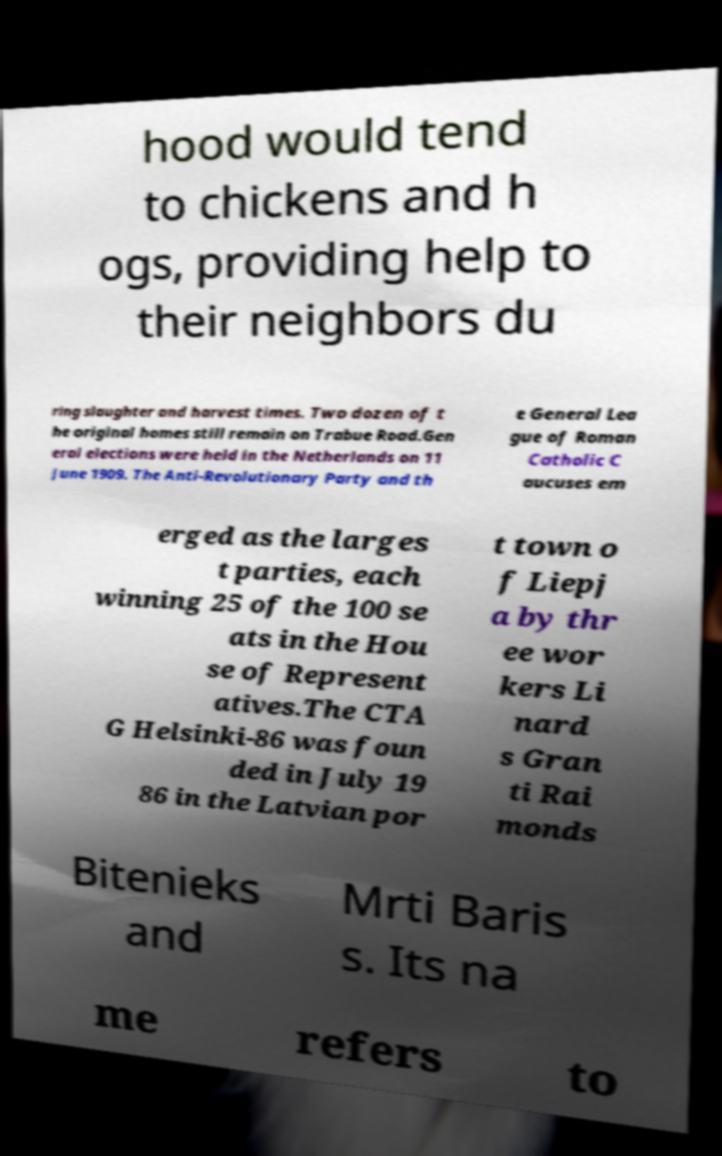Please read and relay the text visible in this image. What does it say? hood would tend to chickens and h ogs, providing help to their neighbors du ring slaughter and harvest times. Two dozen of t he original homes still remain on Trabue Road.Gen eral elections were held in the Netherlands on 11 June 1909. The Anti-Revolutionary Party and th e General Lea gue of Roman Catholic C aucuses em erged as the larges t parties, each winning 25 of the 100 se ats in the Hou se of Represent atives.The CTA G Helsinki-86 was foun ded in July 19 86 in the Latvian por t town o f Liepj a by thr ee wor kers Li nard s Gran ti Rai monds Bitenieks and Mrti Baris s. Its na me refers to 